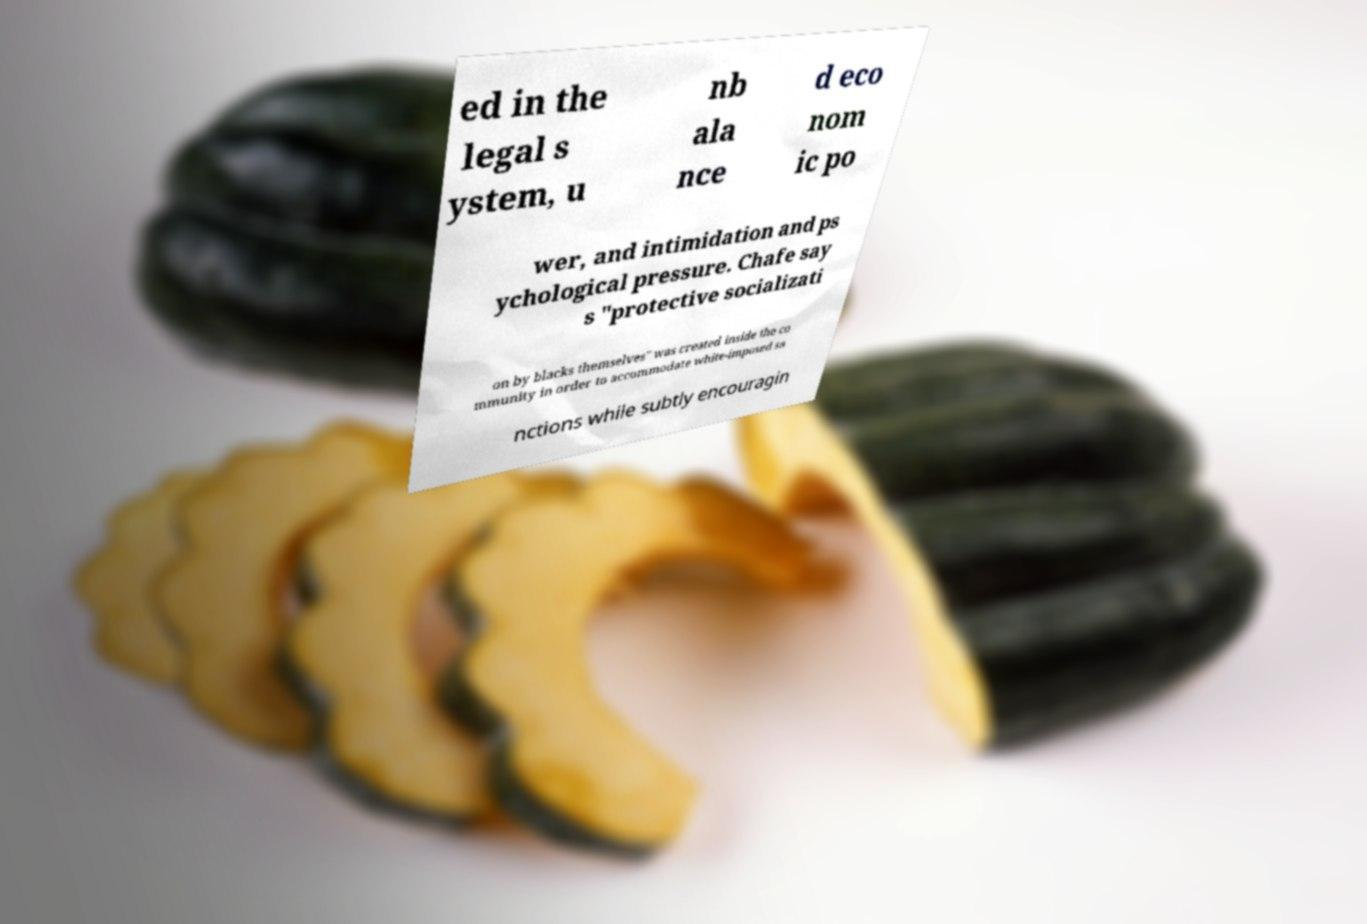Can you accurately transcribe the text from the provided image for me? ed in the legal s ystem, u nb ala nce d eco nom ic po wer, and intimidation and ps ychological pressure. Chafe say s "protective socializati on by blacks themselves" was created inside the co mmunity in order to accommodate white-imposed sa nctions while subtly encouragin 